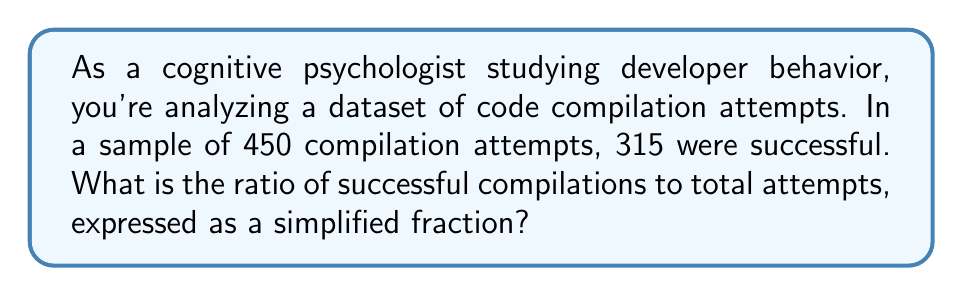Could you help me with this problem? To solve this problem, we need to follow these steps:

1. Identify the given information:
   - Total compilation attempts: 450
   - Successful compilations: 315

2. Set up the ratio of successful compilations to total attempts:
   $$\frac{\text{Successful compilations}}{\text{Total attempts}} = \frac{315}{450}$$

3. Simplify the fraction by finding the greatest common divisor (GCD) of 315 and 450:
   The GCD of 315 and 450 is 45.

4. Divide both the numerator and denominator by the GCD:
   $$\frac{315 \div 45}{450 \div 45} = \frac{315 \div 45}{450 \div 45} = \frac{7}{10}$$

Thus, the simplified ratio of successful compilations to total attempts is 7:10.
Answer: $\frac{7}{10}$ or 7:10 